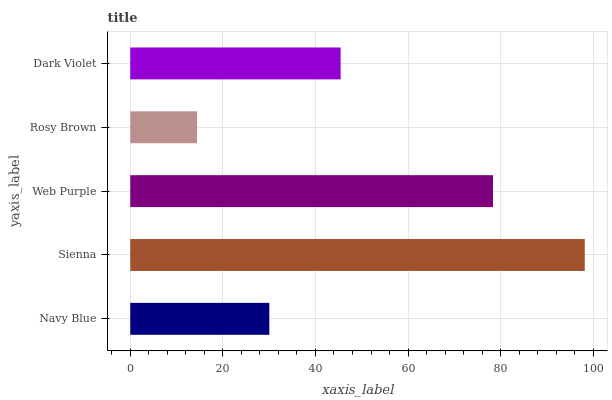Is Rosy Brown the minimum?
Answer yes or no. Yes. Is Sienna the maximum?
Answer yes or no. Yes. Is Web Purple the minimum?
Answer yes or no. No. Is Web Purple the maximum?
Answer yes or no. No. Is Sienna greater than Web Purple?
Answer yes or no. Yes. Is Web Purple less than Sienna?
Answer yes or no. Yes. Is Web Purple greater than Sienna?
Answer yes or no. No. Is Sienna less than Web Purple?
Answer yes or no. No. Is Dark Violet the high median?
Answer yes or no. Yes. Is Dark Violet the low median?
Answer yes or no. Yes. Is Navy Blue the high median?
Answer yes or no. No. Is Sienna the low median?
Answer yes or no. No. 